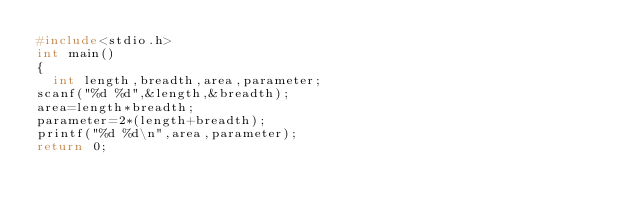<code> <loc_0><loc_0><loc_500><loc_500><_C_>#include<stdio.h>
int main()
{
  int length,breadth,area,parameter;
scanf("%d %d",&length,&breadth);
area=length*breadth;
parameter=2*(length+breadth);
printf("%d %d\n",area,parameter);
return 0;

</code> 